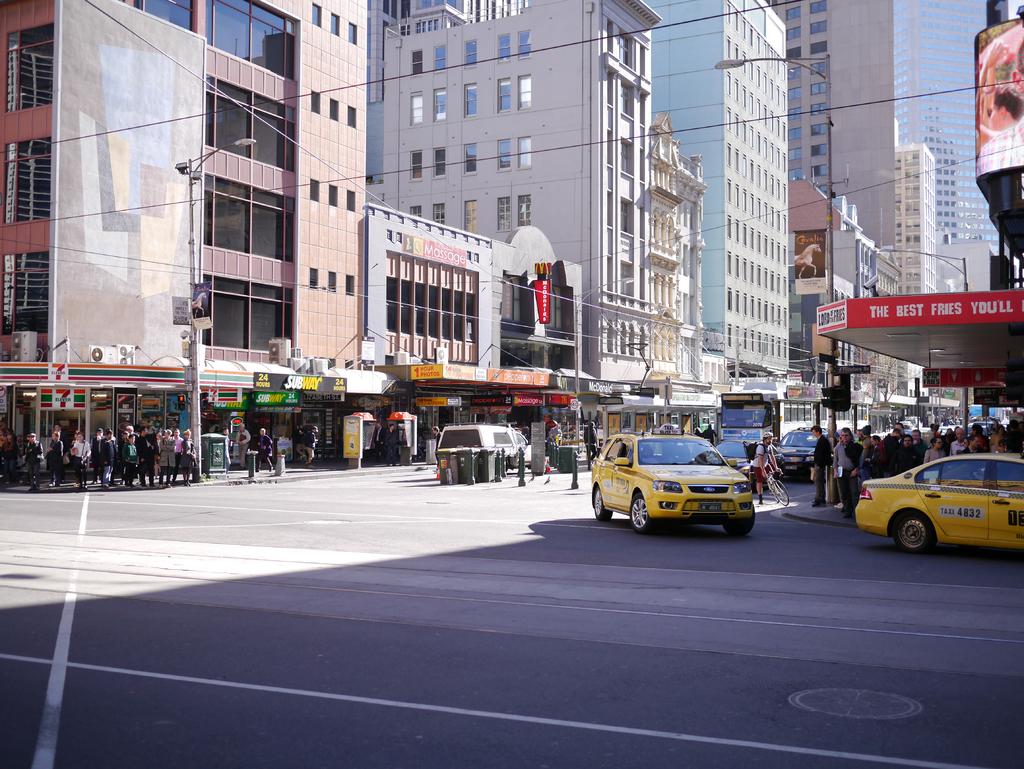The red banner says the best what?
Your response must be concise. Fries. What is the number of the taxi car?
Provide a succinct answer. 4832. 